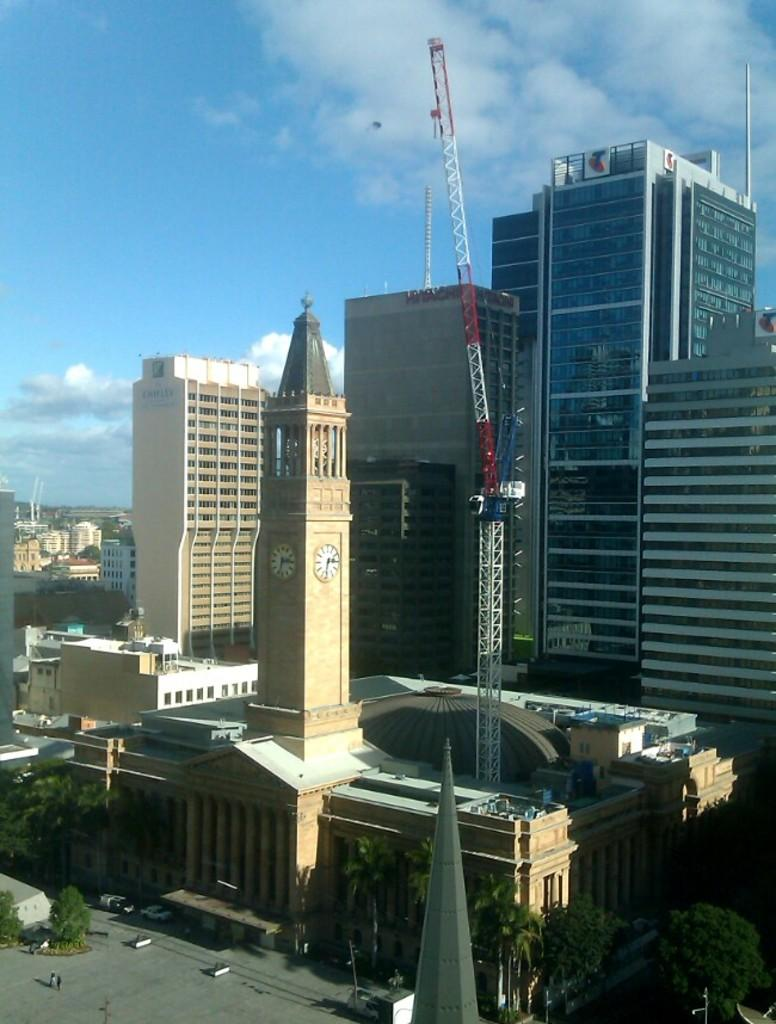What is located in the center of the image? There are buildings, poles, trees, vehicles, and a clock tower in the center of the image. What can be seen above the center of the image? The sky is visible in the background of the image. What is present in the sky? Clouds are present in the background of the image. What type of stone is being advertised in the image? There is no advertisement or stone present in the image. What are the people in the image having for lunch? There are no people or lunch depicted in the image. 